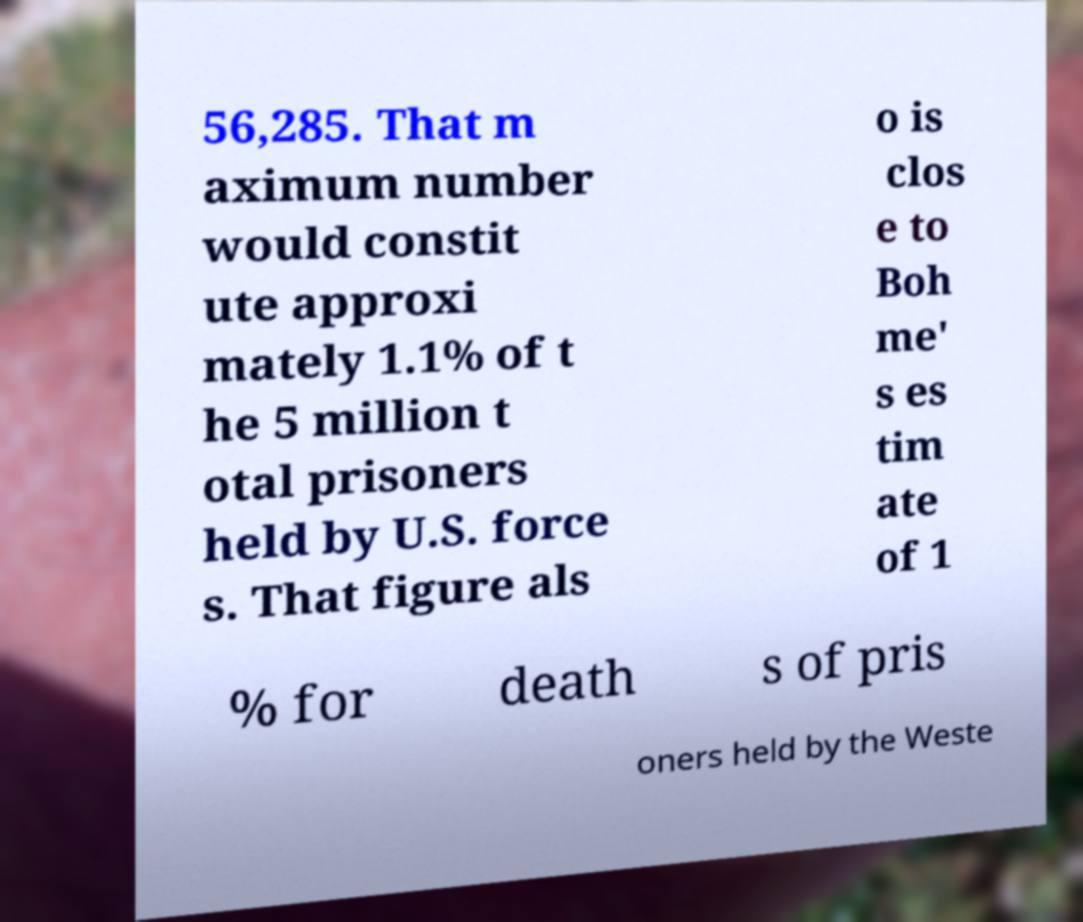Can you read and provide the text displayed in the image?This photo seems to have some interesting text. Can you extract and type it out for me? 56,285. That m aximum number would constit ute approxi mately 1.1% of t he 5 million t otal prisoners held by U.S. force s. That figure als o is clos e to Boh me' s es tim ate of 1 % for death s of pris oners held by the Weste 